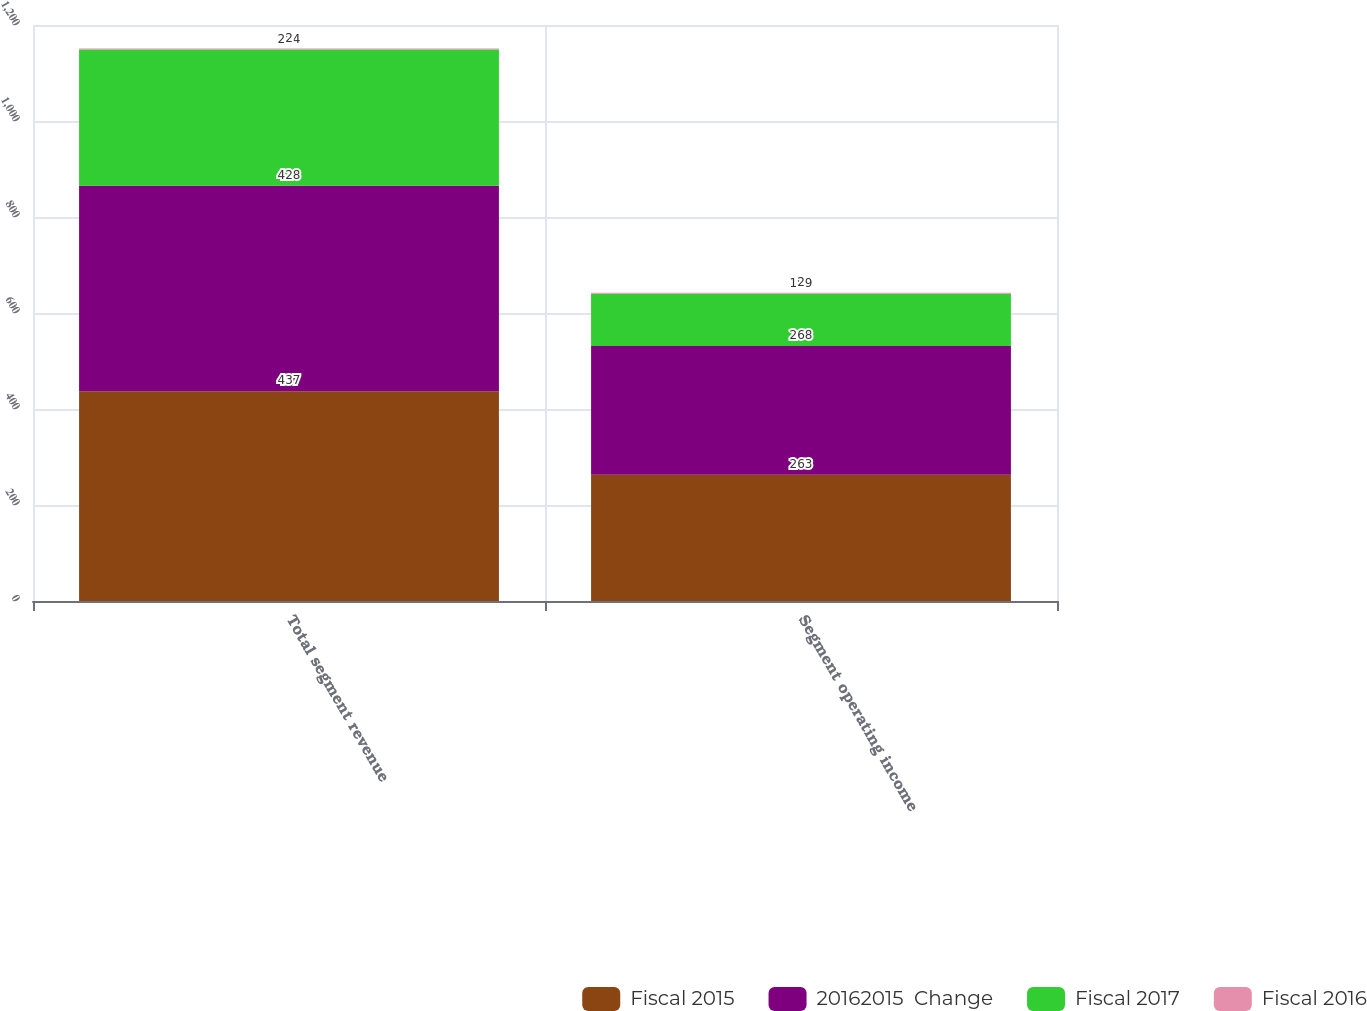Convert chart to OTSL. <chart><loc_0><loc_0><loc_500><loc_500><stacked_bar_chart><ecel><fcel>Total segment revenue<fcel>Segment operating income<nl><fcel>Fiscal 2015<fcel>437<fcel>263<nl><fcel>20162015  Change<fcel>428<fcel>268<nl><fcel>Fiscal 2017<fcel>284<fcel>109<nl><fcel>Fiscal 2016<fcel>2<fcel>2<nl></chart> 